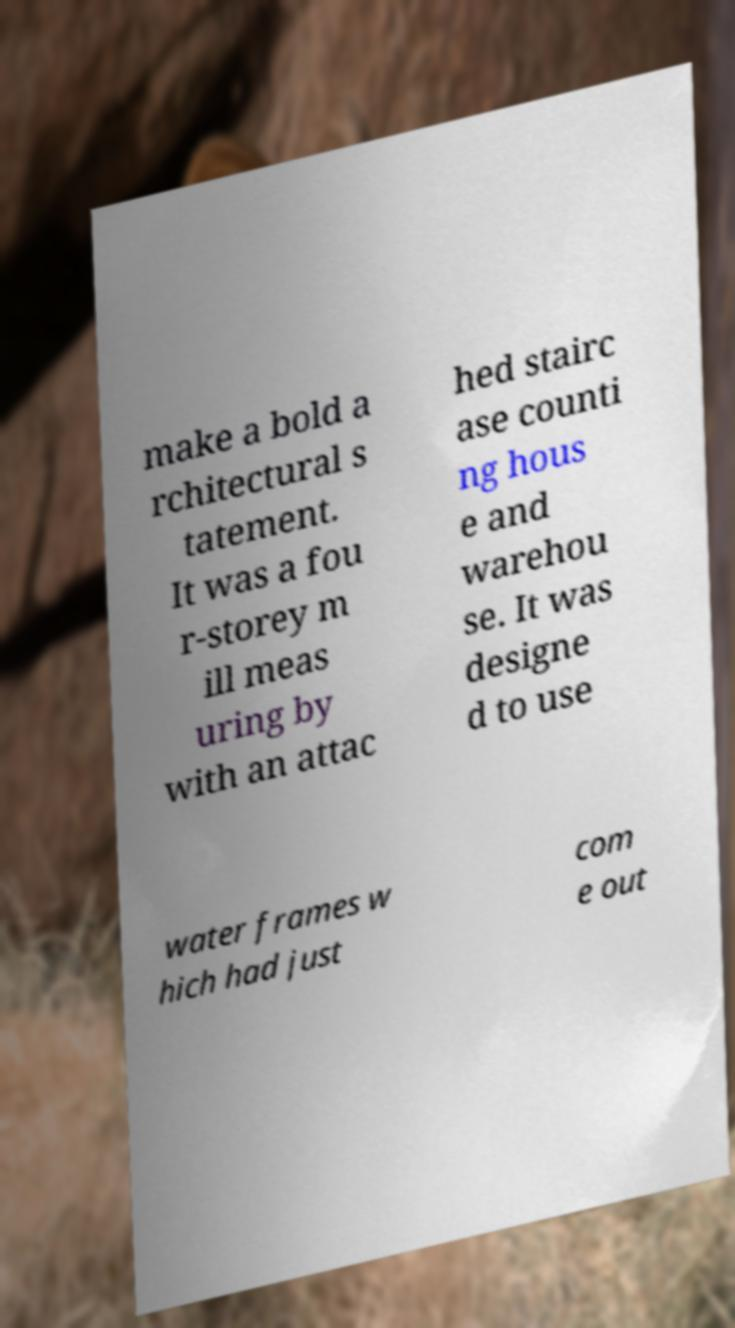Could you extract and type out the text from this image? make a bold a rchitectural s tatement. It was a fou r-storey m ill meas uring by with an attac hed stairc ase counti ng hous e and warehou se. It was designe d to use water frames w hich had just com e out 